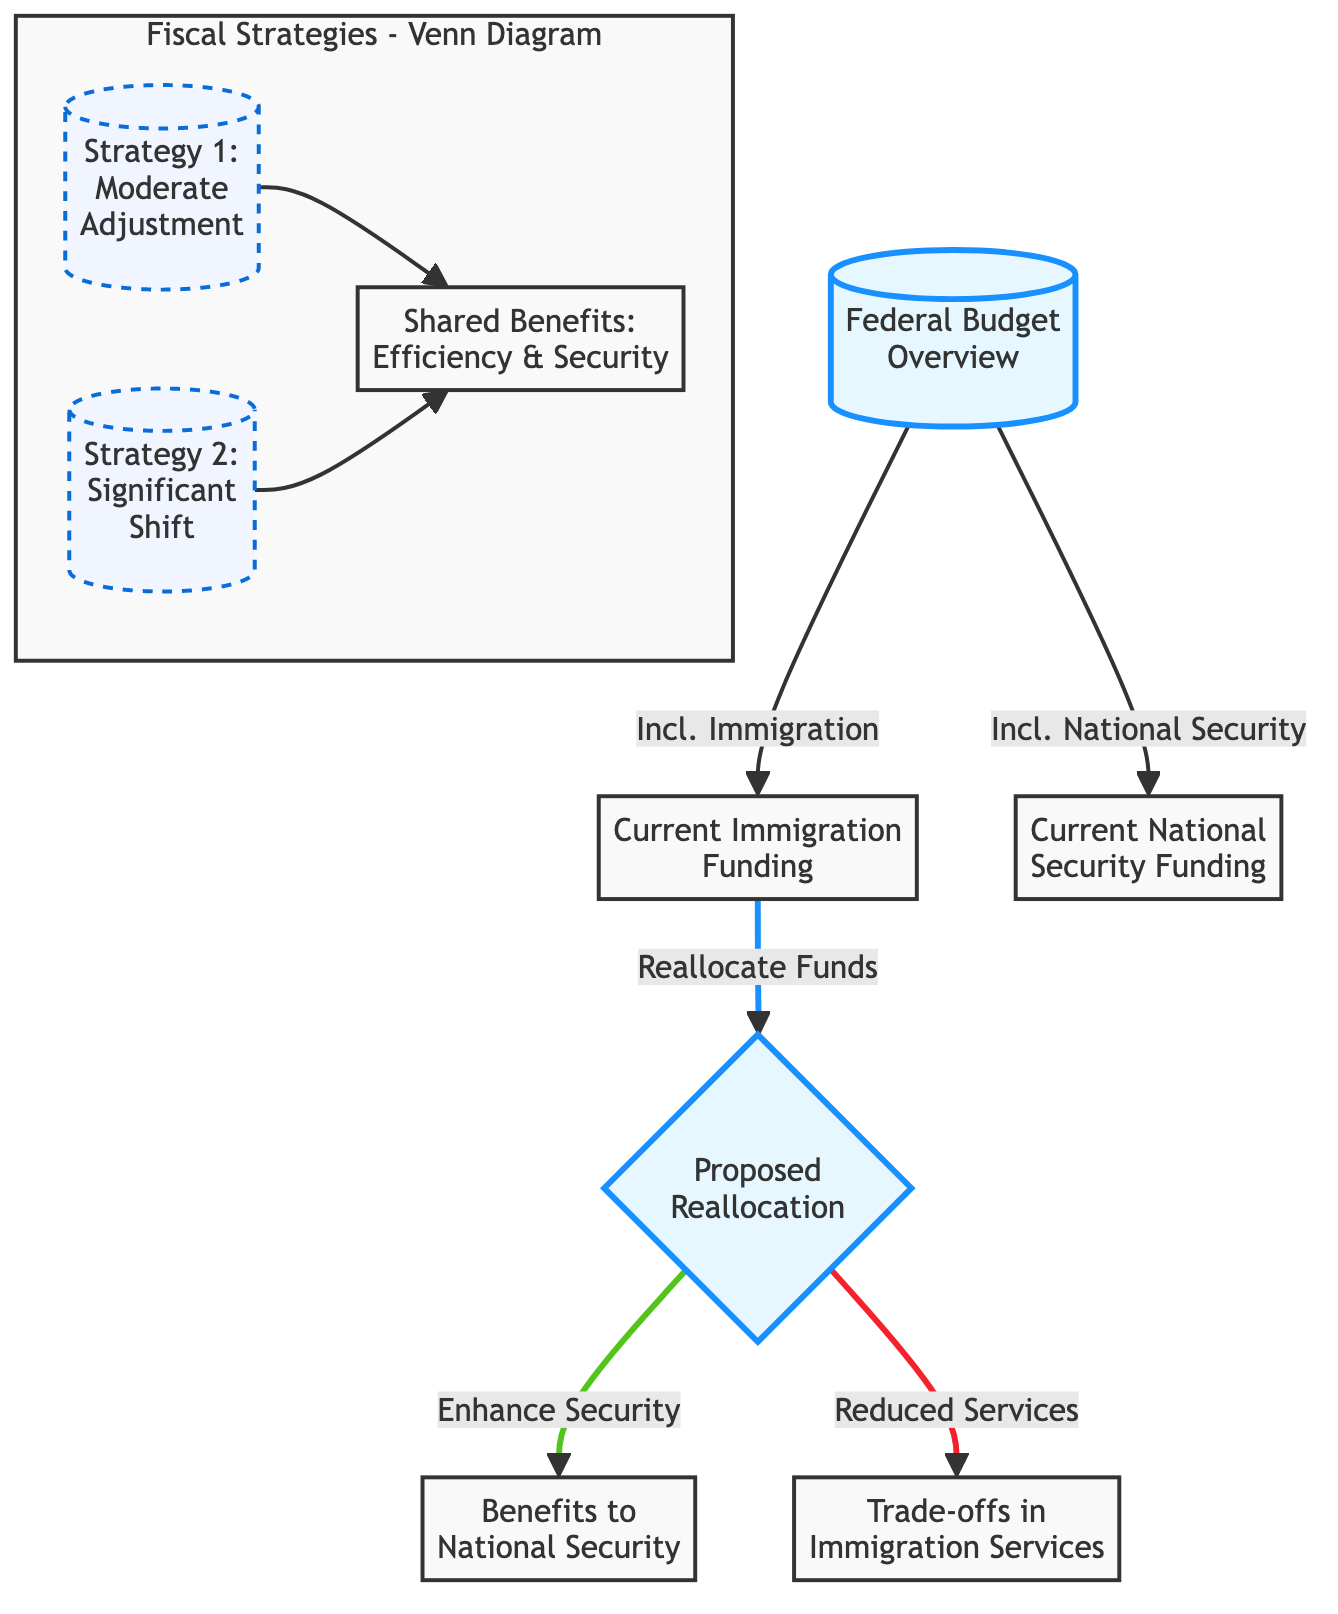What is the focus of the proposed reallocation? The diagram shows that the proposed reallocation focuses on enhancing national security, as indicated by the link from the proposed reallocation node to the benefits for national security node.
Answer: Enhance Security What are the current funding areas represented in the flowchart? The flowchart includes two areas of current funding: immigration funding and national security funding, each represented by separate nodes linked to the federal budget overview.
Answer: Immigration Funding, National Security Funding What are the trade-offs mentioned in the diagram? The diagram lists trade-offs associated with immigration services as a result of the proposed reallocation, indicated by the link from proposed reallocation to the trade-offs in immigration services node.
Answer: Trade-offs in Immigration Services How many strategies are depicted in the Venn diagram? The Venn diagram includes two strategies depicted as separate nodes: Strategy 1 and Strategy 2, showing a total of two distinct strategies.
Answer: 2 What do the shared benefits in the Venn diagram imply? The shared benefits node states "Efficiency & Security," suggesting that both strategies aim for improvements in these areas as a common outcome, shown in the intersection of the two strategy nodes.
Answer: Efficiency & Security Which funding area gets reallocating funds according to the diagram? The diagram indicates that funds are to be reallocated from current immigration funding as shown by the directed link from the current immigration funding node to the proposed reallocation node.
Answer: Current Immigration Funding What is the relationship between the proposed reallocation and benefits to national security? The diagram illustrates a direct connection between the proposed reallocation and the benefits to national security, indicating that reallocating funds is intended to enhance national security efforts.
Answer: Enhance National Security What is the link style for the proposed reallocation in the flowchart? The link style for the proposed reallocation is represented in red, as indicated by the linkStyle instruction for the proposed reallocation, which defines its stroke color and width.
Answer: Stroke color: Red How does the diagram represent the benefits of enhancing national security? The benefits of enhancing national security are represented as a node that is reached directly from the proposed reallocation, indicating a positive outcome of reallocating funds.
Answer: Positive Outcome 